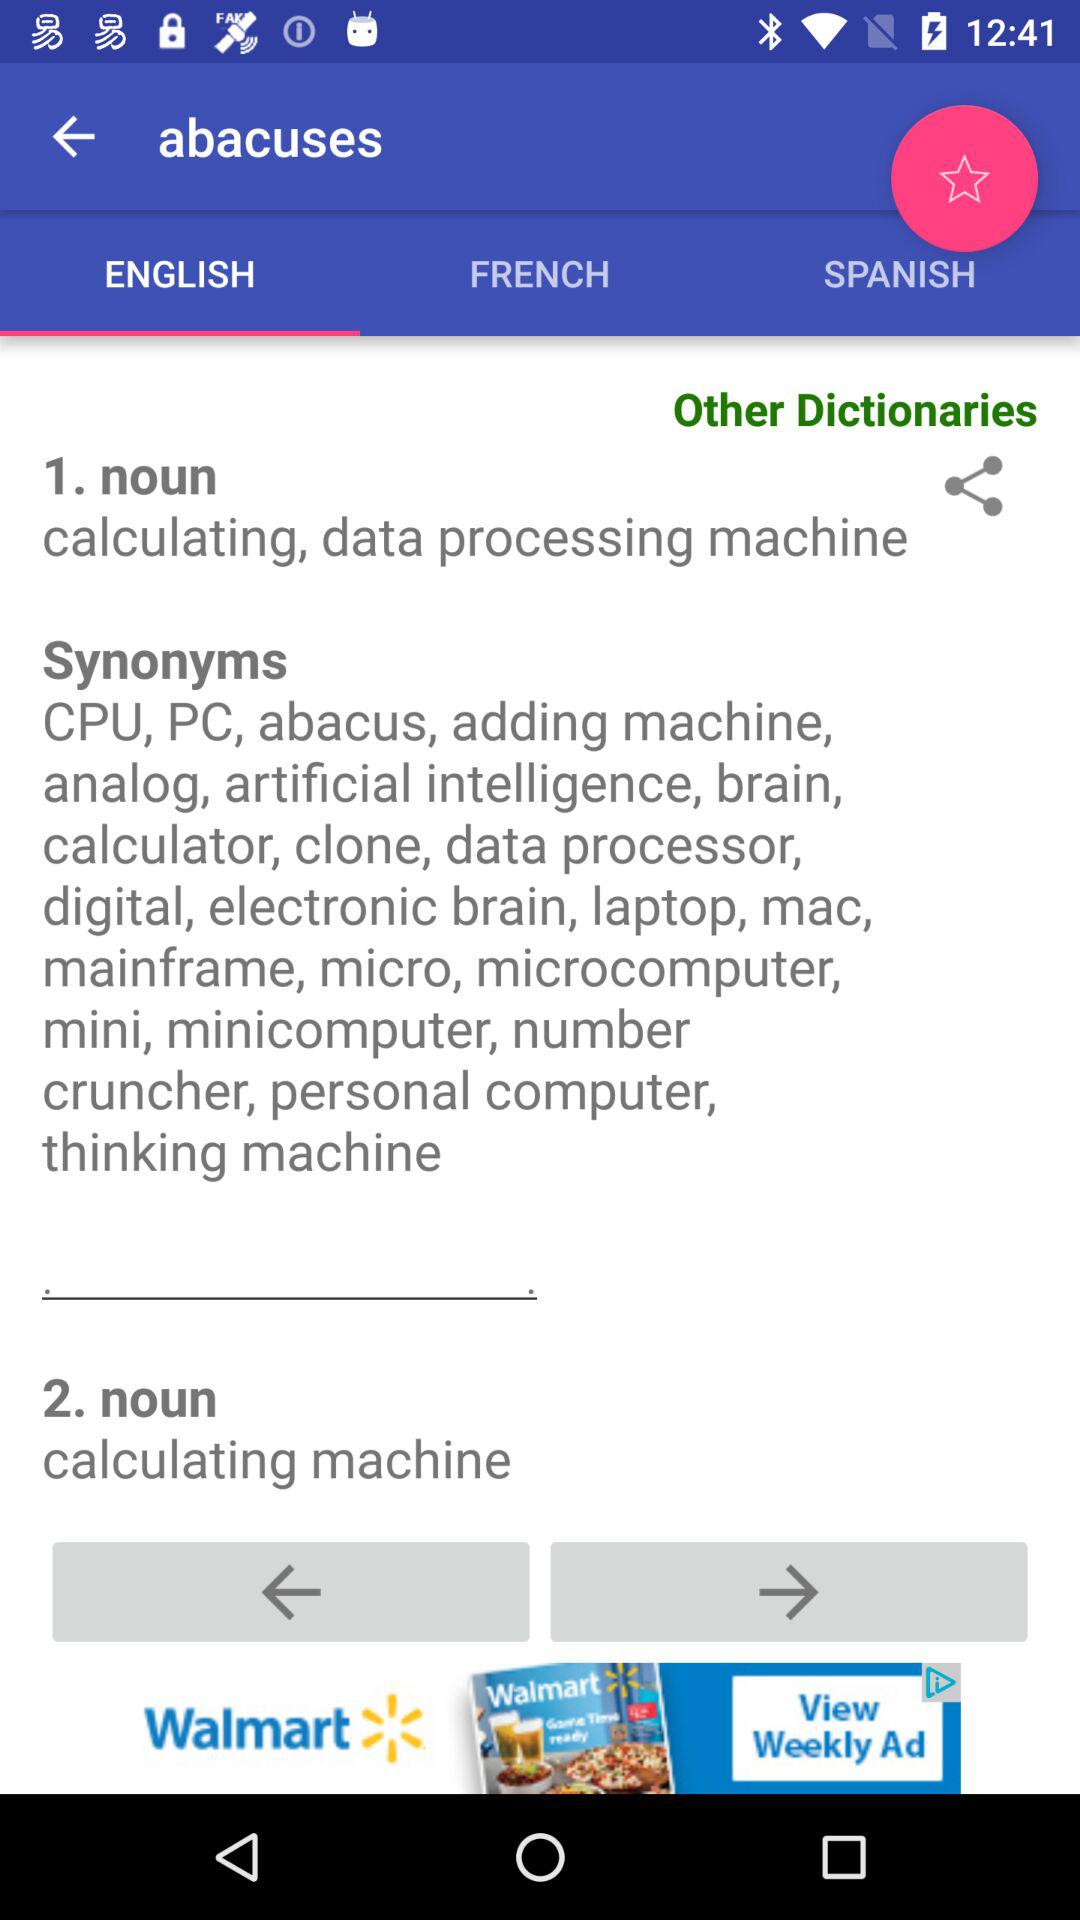What is the word whose meaning is being searched for? The word is "abacuses". 